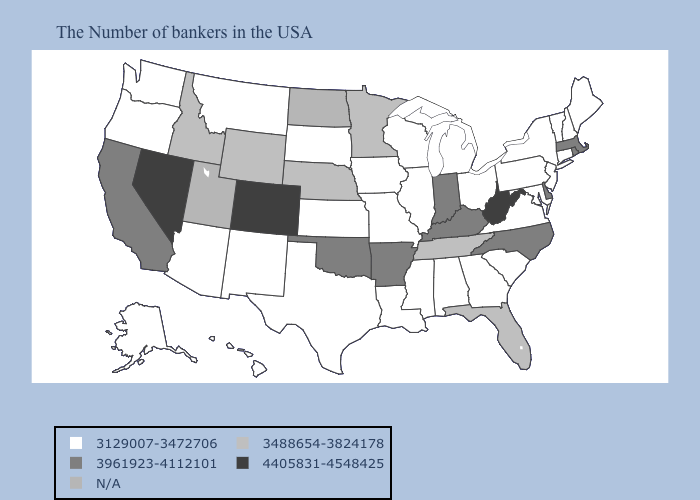What is the value of Kansas?
Quick response, please. 3129007-3472706. Name the states that have a value in the range 3488654-3824178?
Concise answer only. Florida, Tennessee, Minnesota, Nebraska, Wyoming, Idaho. Does Indiana have the highest value in the MidWest?
Keep it brief. Yes. Does Texas have the highest value in the South?
Give a very brief answer. No. What is the lowest value in the USA?
Keep it brief. 3129007-3472706. Does New Jersey have the lowest value in the Northeast?
Keep it brief. Yes. Among the states that border Maryland , which have the highest value?
Short answer required. West Virginia. Name the states that have a value in the range 3961923-4112101?
Quick response, please. Massachusetts, Rhode Island, Delaware, North Carolina, Kentucky, Indiana, Arkansas, Oklahoma, California. Does New Jersey have the lowest value in the Northeast?
Concise answer only. Yes. Does Texas have the highest value in the USA?
Concise answer only. No. Does the map have missing data?
Concise answer only. Yes. What is the value of Illinois?
Be succinct. 3129007-3472706. What is the highest value in the West ?
Be succinct. 4405831-4548425. What is the value of Vermont?
Keep it brief. 3129007-3472706. 